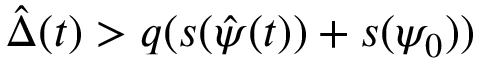<formula> <loc_0><loc_0><loc_500><loc_500>\hat { \Delta } ( t ) > q ( s ( \hat { \psi } ( t ) ) + s ( \psi _ { 0 } ) )</formula> 